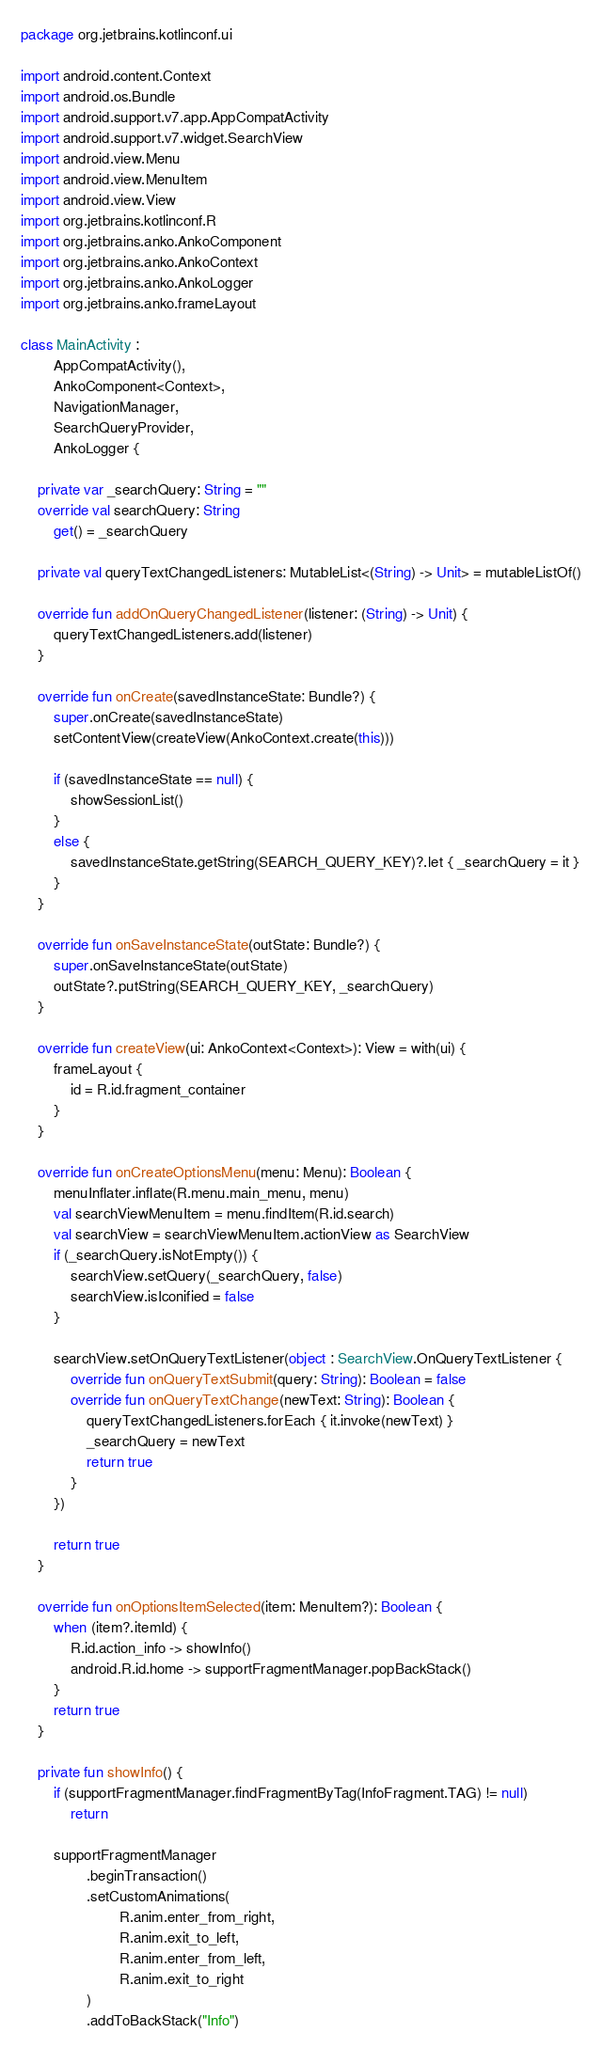Convert code to text. <code><loc_0><loc_0><loc_500><loc_500><_Kotlin_>package org.jetbrains.kotlinconf.ui

import android.content.Context
import android.os.Bundle
import android.support.v7.app.AppCompatActivity
import android.support.v7.widget.SearchView
import android.view.Menu
import android.view.MenuItem
import android.view.View
import org.jetbrains.kotlinconf.R
import org.jetbrains.anko.AnkoComponent
import org.jetbrains.anko.AnkoContext
import org.jetbrains.anko.AnkoLogger
import org.jetbrains.anko.frameLayout

class MainActivity :
        AppCompatActivity(),
        AnkoComponent<Context>,
        NavigationManager,
        SearchQueryProvider,
        AnkoLogger {

    private var _searchQuery: String = ""
    override val searchQuery: String
        get() = _searchQuery

    private val queryTextChangedListeners: MutableList<(String) -> Unit> = mutableListOf()

    override fun addOnQueryChangedListener(listener: (String) -> Unit) {
        queryTextChangedListeners.add(listener)
    }

    override fun onCreate(savedInstanceState: Bundle?) {
        super.onCreate(savedInstanceState)
        setContentView(createView(AnkoContext.create(this)))

        if (savedInstanceState == null) {
            showSessionList()
        }
        else {
            savedInstanceState.getString(SEARCH_QUERY_KEY)?.let { _searchQuery = it }
        }
    }

    override fun onSaveInstanceState(outState: Bundle?) {
        super.onSaveInstanceState(outState)
        outState?.putString(SEARCH_QUERY_KEY, _searchQuery)
    }

    override fun createView(ui: AnkoContext<Context>): View = with(ui) {
        frameLayout {
            id = R.id.fragment_container
        }
    }

    override fun onCreateOptionsMenu(menu: Menu): Boolean {
        menuInflater.inflate(R.menu.main_menu, menu)
        val searchViewMenuItem = menu.findItem(R.id.search)
        val searchView = searchViewMenuItem.actionView as SearchView
        if (_searchQuery.isNotEmpty()) {
            searchView.setQuery(_searchQuery, false)
            searchView.isIconified = false
        }

        searchView.setOnQueryTextListener(object : SearchView.OnQueryTextListener {
            override fun onQueryTextSubmit(query: String): Boolean = false
            override fun onQueryTextChange(newText: String): Boolean {
                queryTextChangedListeners.forEach { it.invoke(newText) }
                _searchQuery = newText
                return true
            }
        })

        return true
    }

    override fun onOptionsItemSelected(item: MenuItem?): Boolean {
        when (item?.itemId) {
            R.id.action_info -> showInfo()
            android.R.id.home -> supportFragmentManager.popBackStack()
        }
        return true
    }

    private fun showInfo() {
        if (supportFragmentManager.findFragmentByTag(InfoFragment.TAG) != null)
            return

        supportFragmentManager
                .beginTransaction()
                .setCustomAnimations(
                        R.anim.enter_from_right,
                        R.anim.exit_to_left,
                        R.anim.enter_from_left,
                        R.anim.exit_to_right
                )
                .addToBackStack("Info")</code> 